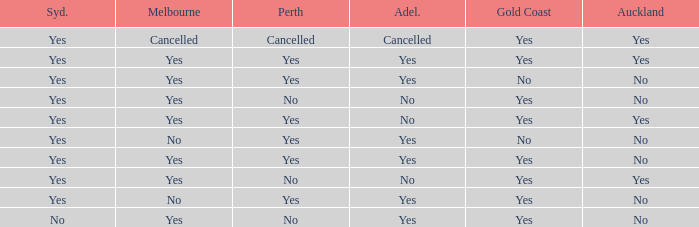What is The Melbourne with a No- Gold Coast Yes, No. 